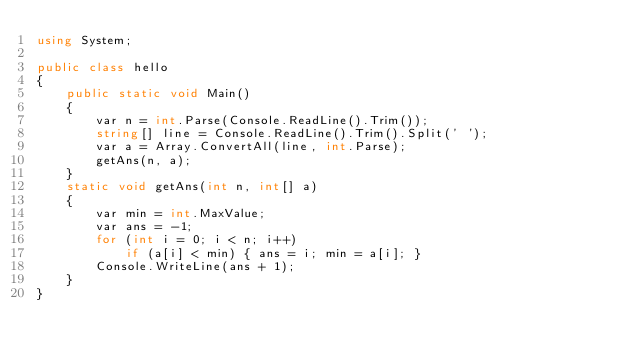<code> <loc_0><loc_0><loc_500><loc_500><_C#_>using System;

public class hello
{
    public static void Main()
    {
        var n = int.Parse(Console.ReadLine().Trim());
        string[] line = Console.ReadLine().Trim().Split(' ');
        var a = Array.ConvertAll(line, int.Parse);
        getAns(n, a);
    }
    static void getAns(int n, int[] a)
    {
        var min = int.MaxValue;
        var ans = -1;
        for (int i = 0; i < n; i++)
            if (a[i] < min) { ans = i; min = a[i]; }
        Console.WriteLine(ans + 1);
    }
}

</code> 